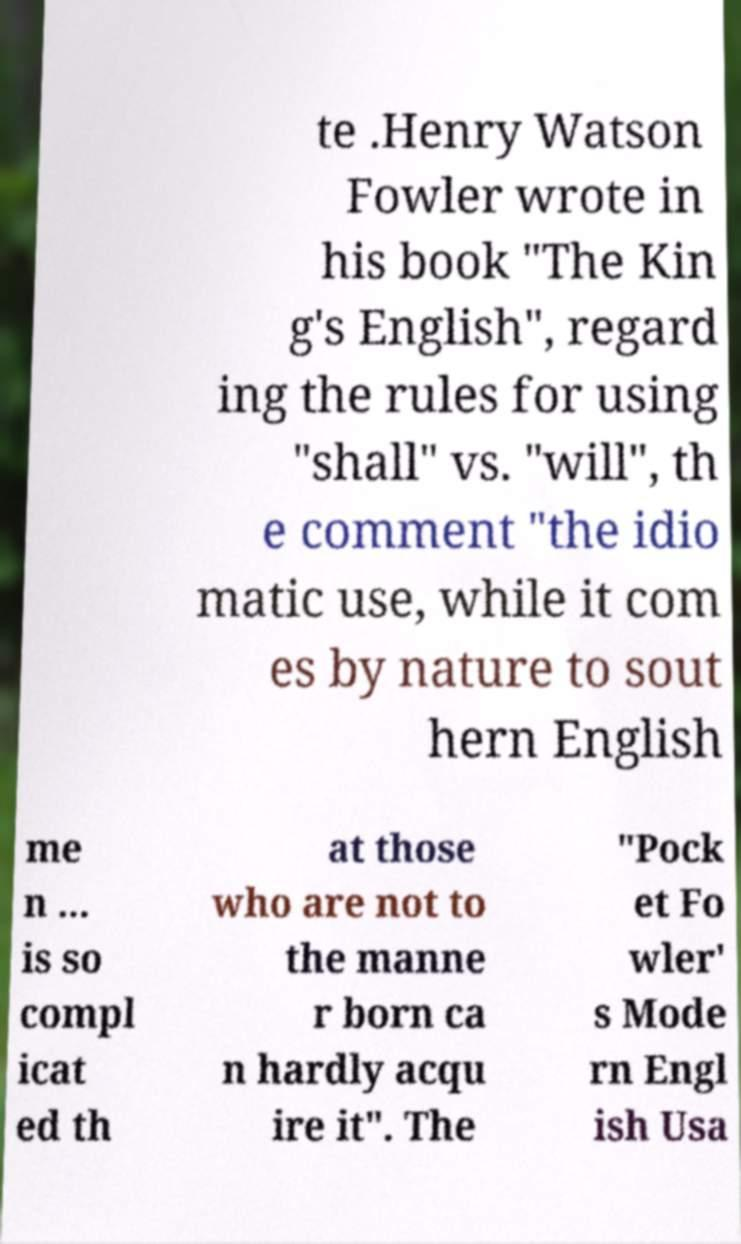What messages or text are displayed in this image? I need them in a readable, typed format. te .Henry Watson Fowler wrote in his book "The Kin g's English", regard ing the rules for using "shall" vs. "will", th e comment "the idio matic use, while it com es by nature to sout hern English me n ... is so compl icat ed th at those who are not to the manne r born ca n hardly acqu ire it". The "Pock et Fo wler' s Mode rn Engl ish Usa 